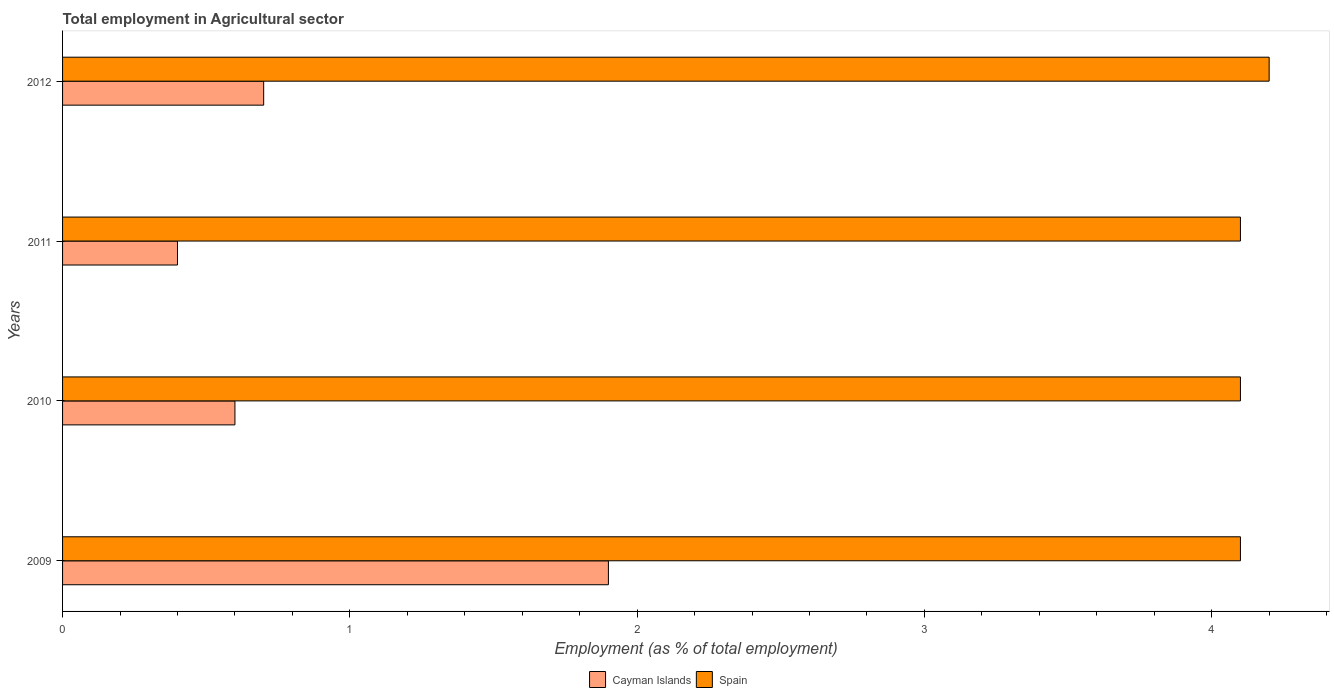How many different coloured bars are there?
Your answer should be compact. 2. How many groups of bars are there?
Your answer should be compact. 4. Are the number of bars per tick equal to the number of legend labels?
Ensure brevity in your answer.  Yes. Are the number of bars on each tick of the Y-axis equal?
Make the answer very short. Yes. How many bars are there on the 1st tick from the top?
Make the answer very short. 2. How many bars are there on the 1st tick from the bottom?
Make the answer very short. 2. What is the employment in agricultural sector in Spain in 2010?
Your answer should be compact. 4.1. Across all years, what is the maximum employment in agricultural sector in Spain?
Make the answer very short. 4.2. Across all years, what is the minimum employment in agricultural sector in Cayman Islands?
Your response must be concise. 0.4. In which year was the employment in agricultural sector in Cayman Islands maximum?
Provide a succinct answer. 2009. In which year was the employment in agricultural sector in Cayman Islands minimum?
Make the answer very short. 2011. What is the total employment in agricultural sector in Cayman Islands in the graph?
Offer a very short reply. 3.6. What is the difference between the employment in agricultural sector in Cayman Islands in 2011 and that in 2012?
Keep it short and to the point. -0.3. What is the difference between the employment in agricultural sector in Spain in 2010 and the employment in agricultural sector in Cayman Islands in 2012?
Your answer should be compact. 3.4. What is the average employment in agricultural sector in Spain per year?
Your response must be concise. 4.12. In the year 2012, what is the difference between the employment in agricultural sector in Spain and employment in agricultural sector in Cayman Islands?
Provide a succinct answer. 3.5. In how many years, is the employment in agricultural sector in Spain greater than 1 %?
Offer a terse response. 4. What is the ratio of the employment in agricultural sector in Cayman Islands in 2009 to that in 2011?
Your answer should be very brief. 4.75. Is the employment in agricultural sector in Spain in 2009 less than that in 2012?
Your response must be concise. Yes. What is the difference between the highest and the second highest employment in agricultural sector in Cayman Islands?
Offer a terse response. 1.2. What is the difference between the highest and the lowest employment in agricultural sector in Spain?
Keep it short and to the point. 0.1. Is the sum of the employment in agricultural sector in Spain in 2009 and 2012 greater than the maximum employment in agricultural sector in Cayman Islands across all years?
Give a very brief answer. Yes. What does the 2nd bar from the top in 2009 represents?
Provide a short and direct response. Cayman Islands. What does the 2nd bar from the bottom in 2011 represents?
Your answer should be compact. Spain. Are all the bars in the graph horizontal?
Ensure brevity in your answer.  Yes. What is the difference between two consecutive major ticks on the X-axis?
Your answer should be compact. 1. Are the values on the major ticks of X-axis written in scientific E-notation?
Your answer should be very brief. No. Does the graph contain any zero values?
Keep it short and to the point. No. Does the graph contain grids?
Make the answer very short. No. How many legend labels are there?
Ensure brevity in your answer.  2. What is the title of the graph?
Offer a very short reply. Total employment in Agricultural sector. What is the label or title of the X-axis?
Give a very brief answer. Employment (as % of total employment). What is the Employment (as % of total employment) in Cayman Islands in 2009?
Provide a short and direct response. 1.9. What is the Employment (as % of total employment) of Spain in 2009?
Give a very brief answer. 4.1. What is the Employment (as % of total employment) of Cayman Islands in 2010?
Keep it short and to the point. 0.6. What is the Employment (as % of total employment) of Spain in 2010?
Make the answer very short. 4.1. What is the Employment (as % of total employment) in Cayman Islands in 2011?
Keep it short and to the point. 0.4. What is the Employment (as % of total employment) in Spain in 2011?
Your answer should be compact. 4.1. What is the Employment (as % of total employment) in Cayman Islands in 2012?
Your response must be concise. 0.7. What is the Employment (as % of total employment) in Spain in 2012?
Give a very brief answer. 4.2. Across all years, what is the maximum Employment (as % of total employment) of Cayman Islands?
Offer a very short reply. 1.9. Across all years, what is the maximum Employment (as % of total employment) of Spain?
Give a very brief answer. 4.2. Across all years, what is the minimum Employment (as % of total employment) in Cayman Islands?
Your answer should be compact. 0.4. Across all years, what is the minimum Employment (as % of total employment) of Spain?
Provide a succinct answer. 4.1. What is the total Employment (as % of total employment) in Spain in the graph?
Give a very brief answer. 16.5. What is the difference between the Employment (as % of total employment) in Cayman Islands in 2009 and that in 2010?
Your answer should be very brief. 1.3. What is the difference between the Employment (as % of total employment) in Cayman Islands in 2009 and that in 2011?
Ensure brevity in your answer.  1.5. What is the difference between the Employment (as % of total employment) in Spain in 2010 and that in 2011?
Offer a terse response. 0. What is the difference between the Employment (as % of total employment) of Cayman Islands in 2011 and that in 2012?
Offer a terse response. -0.3. What is the difference between the Employment (as % of total employment) in Cayman Islands in 2009 and the Employment (as % of total employment) in Spain in 2011?
Provide a succinct answer. -2.2. What is the difference between the Employment (as % of total employment) of Cayman Islands in 2009 and the Employment (as % of total employment) of Spain in 2012?
Your answer should be compact. -2.3. What is the difference between the Employment (as % of total employment) of Cayman Islands in 2010 and the Employment (as % of total employment) of Spain in 2012?
Provide a short and direct response. -3.6. What is the difference between the Employment (as % of total employment) of Cayman Islands in 2011 and the Employment (as % of total employment) of Spain in 2012?
Provide a short and direct response. -3.8. What is the average Employment (as % of total employment) of Cayman Islands per year?
Provide a succinct answer. 0.9. What is the average Employment (as % of total employment) in Spain per year?
Give a very brief answer. 4.12. In the year 2011, what is the difference between the Employment (as % of total employment) in Cayman Islands and Employment (as % of total employment) in Spain?
Keep it short and to the point. -3.7. In the year 2012, what is the difference between the Employment (as % of total employment) of Cayman Islands and Employment (as % of total employment) of Spain?
Your answer should be very brief. -3.5. What is the ratio of the Employment (as % of total employment) of Cayman Islands in 2009 to that in 2010?
Give a very brief answer. 3.17. What is the ratio of the Employment (as % of total employment) in Cayman Islands in 2009 to that in 2011?
Offer a very short reply. 4.75. What is the ratio of the Employment (as % of total employment) of Cayman Islands in 2009 to that in 2012?
Your answer should be compact. 2.71. What is the ratio of the Employment (as % of total employment) in Spain in 2009 to that in 2012?
Your response must be concise. 0.98. What is the ratio of the Employment (as % of total employment) of Cayman Islands in 2010 to that in 2011?
Your response must be concise. 1.5. What is the ratio of the Employment (as % of total employment) of Cayman Islands in 2010 to that in 2012?
Provide a succinct answer. 0.86. What is the ratio of the Employment (as % of total employment) of Spain in 2010 to that in 2012?
Offer a very short reply. 0.98. What is the ratio of the Employment (as % of total employment) in Cayman Islands in 2011 to that in 2012?
Provide a succinct answer. 0.57. What is the ratio of the Employment (as % of total employment) in Spain in 2011 to that in 2012?
Your response must be concise. 0.98. What is the difference between the highest and the second highest Employment (as % of total employment) of Cayman Islands?
Your response must be concise. 1.2. What is the difference between the highest and the second highest Employment (as % of total employment) in Spain?
Offer a terse response. 0.1. 